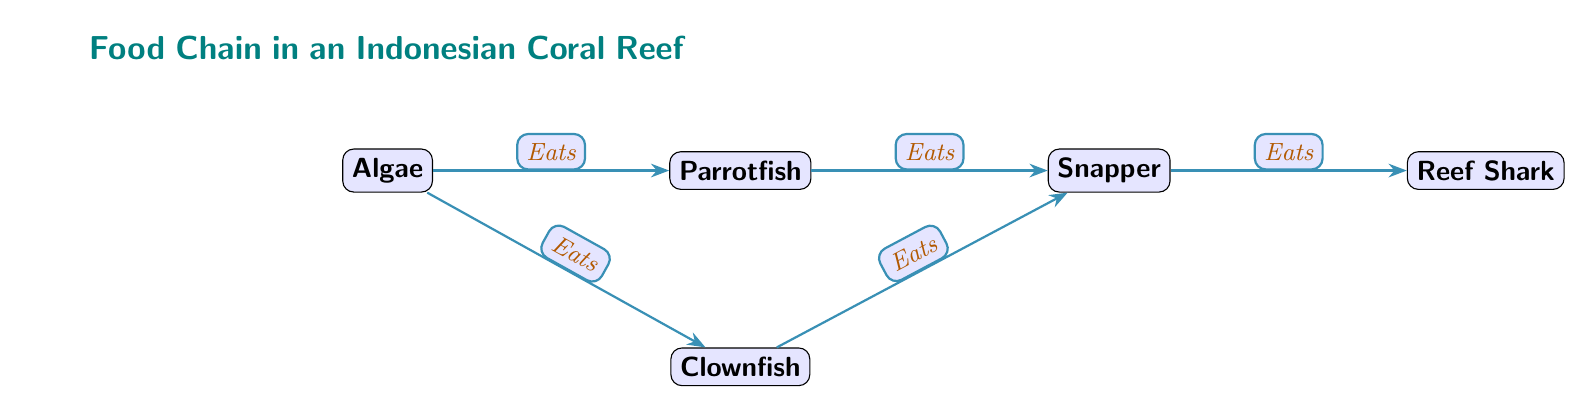What is the first node in the food chain? The food chain starts with algae, as it is the first node connected to other organisms.
Answer: Algae How many nodes are there in the diagram? The diagram contains five nodes: algae, parrotfish, clownfish, snapper, and reef shark, which are all connected in a chain.
Answer: 5 Which organism is eaten by both parrotfish and clownfish? Snapper is listed as being eaten by both parrotfish and clownfish, indicating it is a common prey for both fish.
Answer: Snapper What is the relationship between parrotfish and snapper? Parrotfish eats snapper, as indicated by the directed edge connecting them in the food chain.
Answer: Eats Which organism is at the top of the food chain? Reef shark is the apex predator in this food chain, as it is the last node with no other organisms preying on it.
Answer: Reef Shark What are the two organisms that eat algae? Both parrotfish and clownfish are shown to eat algae, which serves as the primary producer in this food chain.
Answer: Parrotfish and Clownfish Explain the flow of energy from algae to reef shark. The energy flows from algae to parrotfish and clownfish, which both feed on algae; then, the energy continues from them to snapper, which is eaten by reef shark, completing the food chain.
Answer: Algae → Parrotfish/Clownfish → Snapper → Reef Shark How many edges are in the diagram? The diagram contains four edges, which represent the feeding relationships between the nodes in the food chain.
Answer: 4 